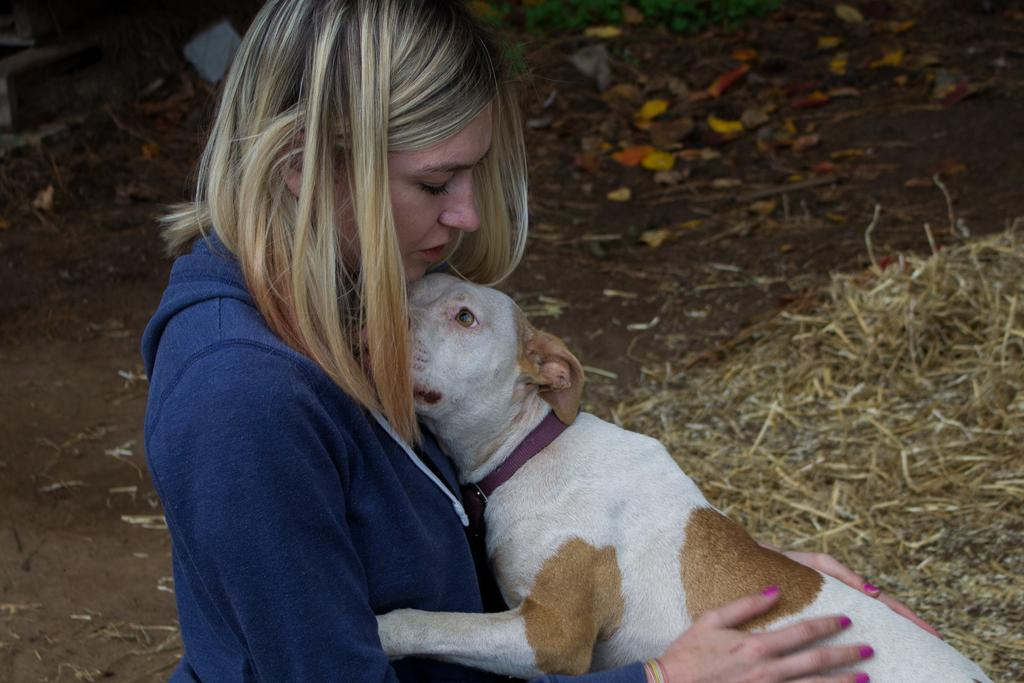Who is present in the image? There is a woman in the image. What is the woman wearing? The woman is wearing a blue jacket. What is the woman holding in the image? The woman is holding a dog. What can be seen in the background of the image? There is a path with leaves and grass visible in the background. What type of coil is used for the woman's digestion in the image? There is no mention of digestion or coils in the image; it features a woman holding a dog and a background with a path, leaves, and grass. 